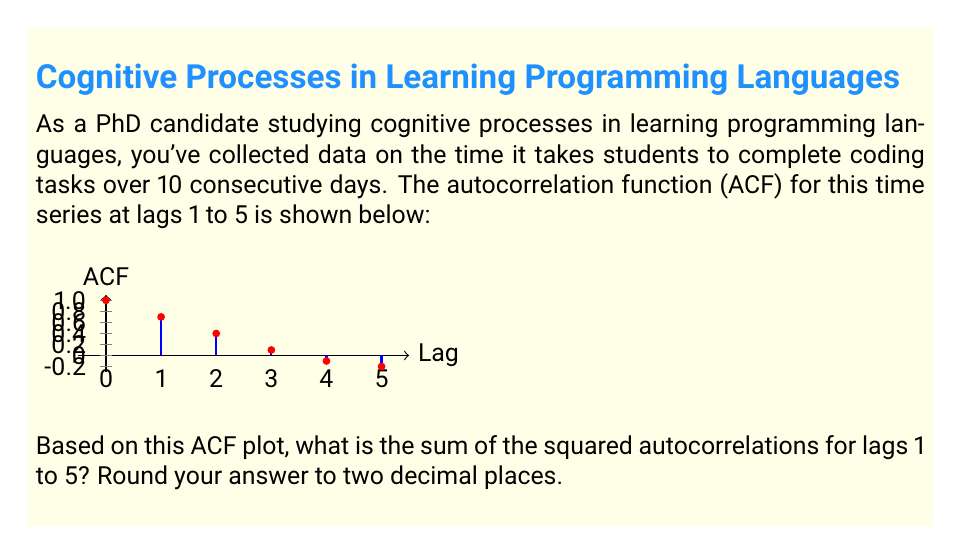Give your solution to this math problem. To solve this problem, we need to follow these steps:

1. Identify the autocorrelation values for lags 1 to 5 from the ACF plot.
2. Square each of these values.
3. Sum the squared values.
4. Round the result to two decimal places.

Let's go through each step:

1. Autocorrelation values from the plot:
   Lag 1: 0.7
   Lag 2: 0.4
   Lag 3: 0.1
   Lag 4: -0.1
   Lag 5: -0.2

2. Squaring each value:
   $$(0.7)^2 = 0.49$$
   $$(0.4)^2 = 0.16$$
   $$(0.1)^2 = 0.01$$
   $$(-0.1)^2 = 0.01$$
   $$(-0.2)^2 = 0.04$$

3. Summing the squared values:
   $$0.49 + 0.16 + 0.01 + 0.01 + 0.04 = 0.71$$

4. Rounding to two decimal places:
   The sum 0.71 is already rounded to two decimal places.

Therefore, the sum of the squared autocorrelations for lags 1 to 5 is 0.71.
Answer: 0.71 